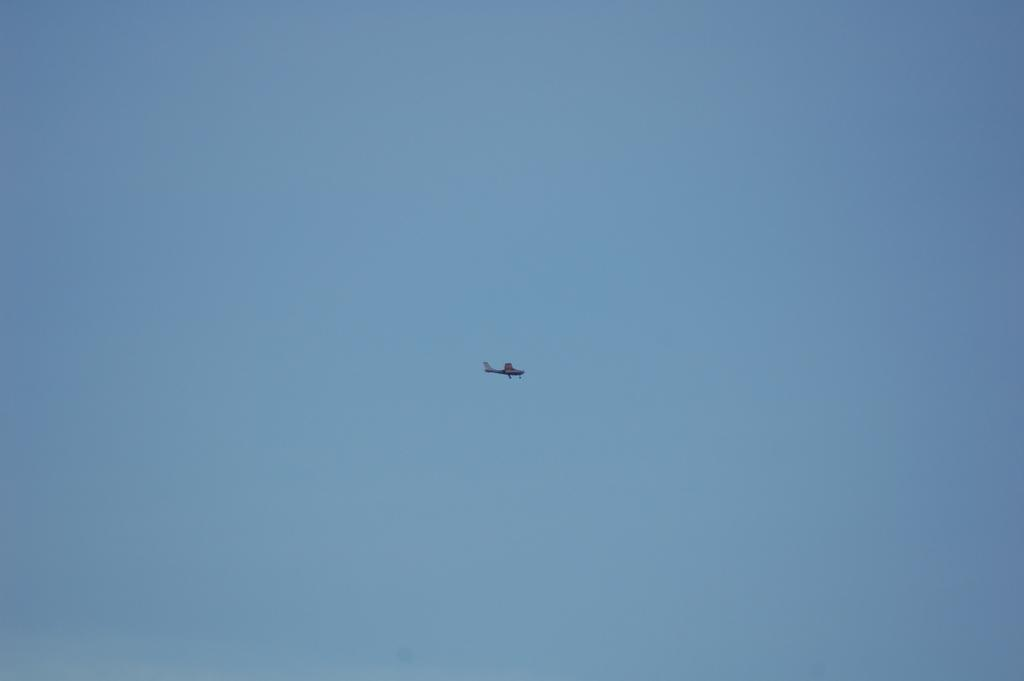What is the main subject of the image? The main subject of the image is an airplane flying in the sky. What part of the image is visible? The sky is visible at the top of the image. How many snails can be seen crawling on the airplane in the image? There are no snails present in the image; it features an airplane flying in the sky. What type of rabbit is sitting in the stomach of the airplane in the image? There is no rabbit present in the image, and the airplane does not have a stomach. 